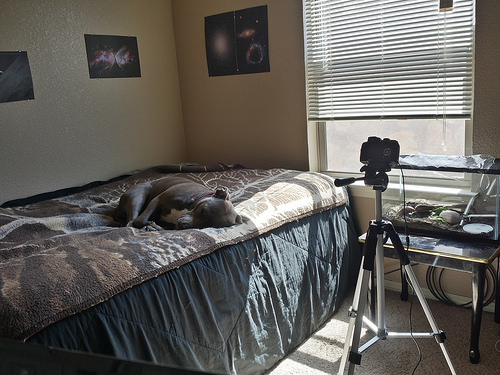<image>
Can you confirm if the blinds is behind the window? No. The blinds is not behind the window. From this viewpoint, the blinds appears to be positioned elsewhere in the scene. Is the dog on the floor? No. The dog is not positioned on the floor. They may be near each other, but the dog is not supported by or resting on top of the floor. Is the tripod to the right of the bed? Yes. From this viewpoint, the tripod is positioned to the right side relative to the bed. 